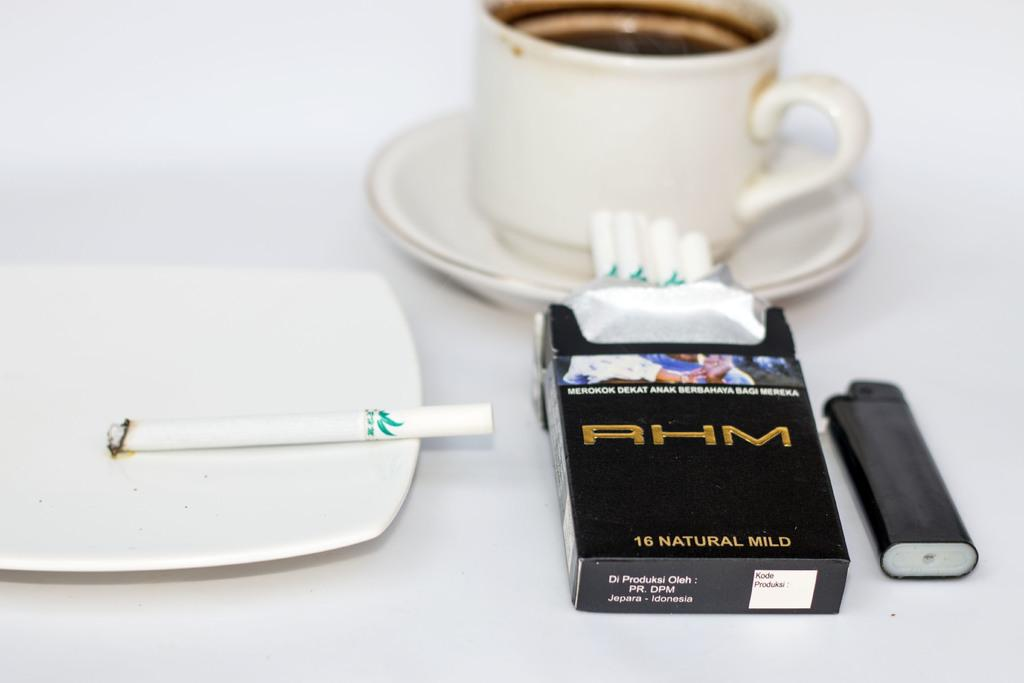What is the color of the tray in the image? The tray in the image is white. What is placed on the tray? There is a cigarette on the tray. What is located behind the tray? There is a white tea cup behind the tray. What is the color of the cigarette packet in the image? The cigarette packet in the image is black. What object is used for lighting the cigarette? A lighter is placed on the table top. What is the price of the sister in the image? There is no sister present in the image, so it is not possible to determine a price. 